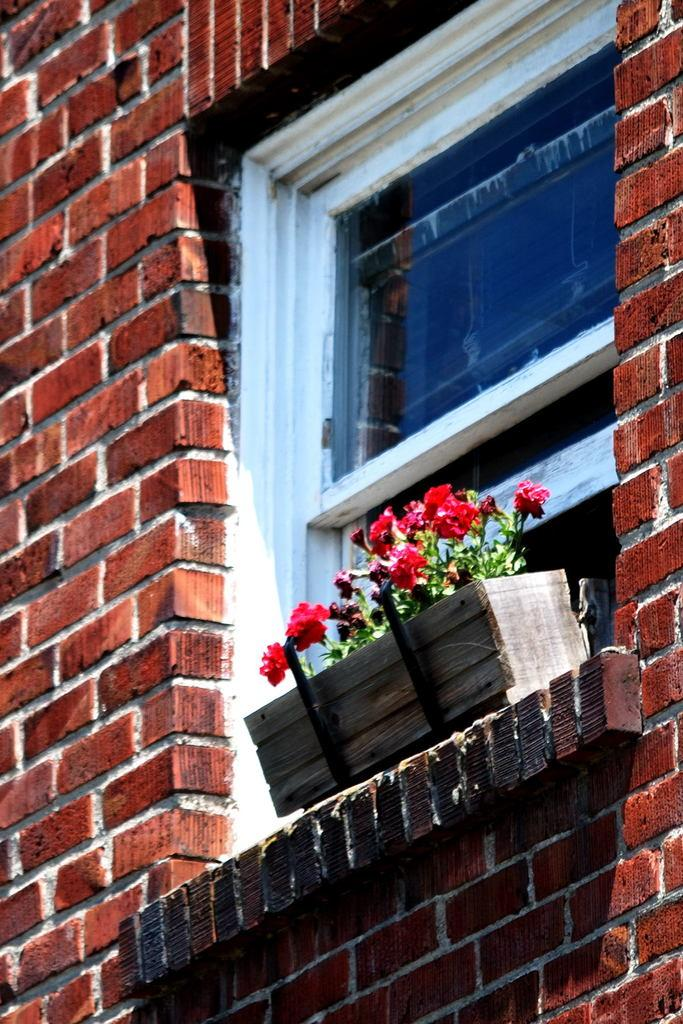What can be seen on the wall in the image? There is a window on the wall in the image. What is located beside the window? There is a wooden box beside the window. What is inside the wooden box? The wooden box contains flower plants. How does the wind affect the sand in the image? There is no sand present in the image, so the wind's effect on sand cannot be observed. 